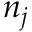<formula> <loc_0><loc_0><loc_500><loc_500>n _ { j }</formula> 